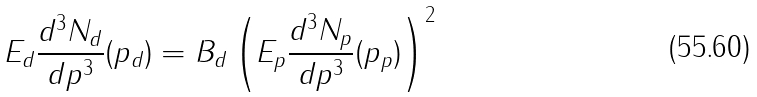<formula> <loc_0><loc_0><loc_500><loc_500>E _ { d } \frac { d ^ { 3 } N _ { d } } { d p ^ { 3 } } ( p _ { d } ) = B _ { d } \left ( E _ { p } \frac { d ^ { 3 } N _ { p } } { d p ^ { 3 } } ( p _ { p } ) \right ) ^ { 2 }</formula> 